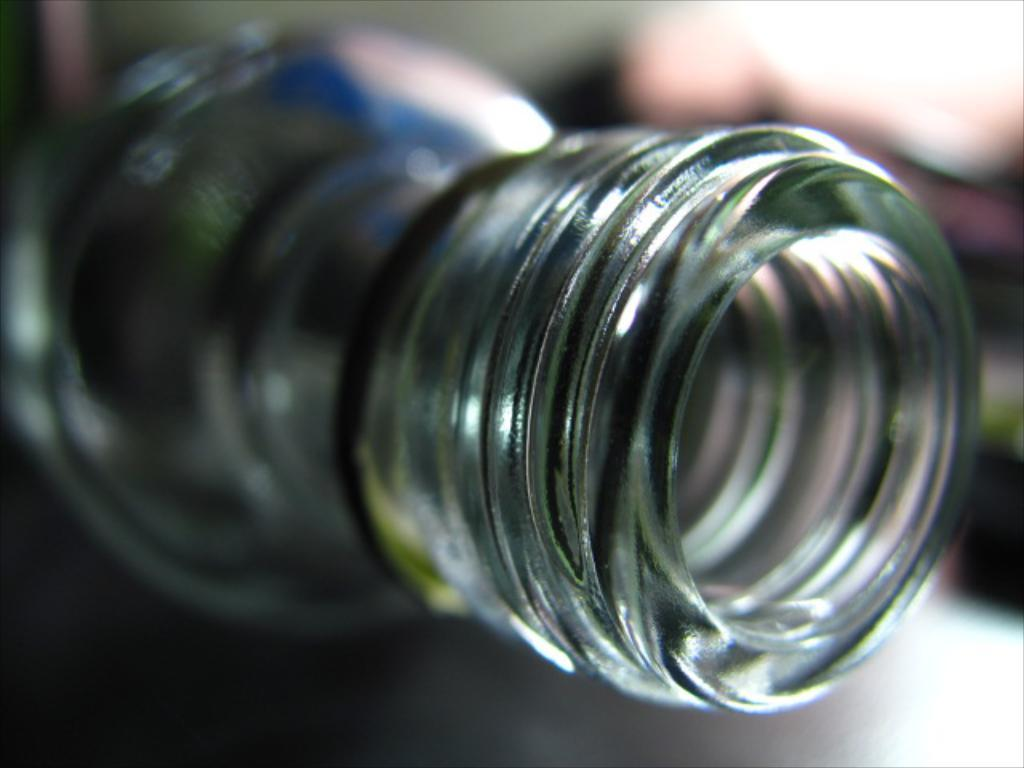What is the main subject of the image? The main subject of the image is the opening of a bottle. How many cows can be seen crushing seeds in the image? There are no cows or seeds present in the image; it only shows the opening of a bottle. 